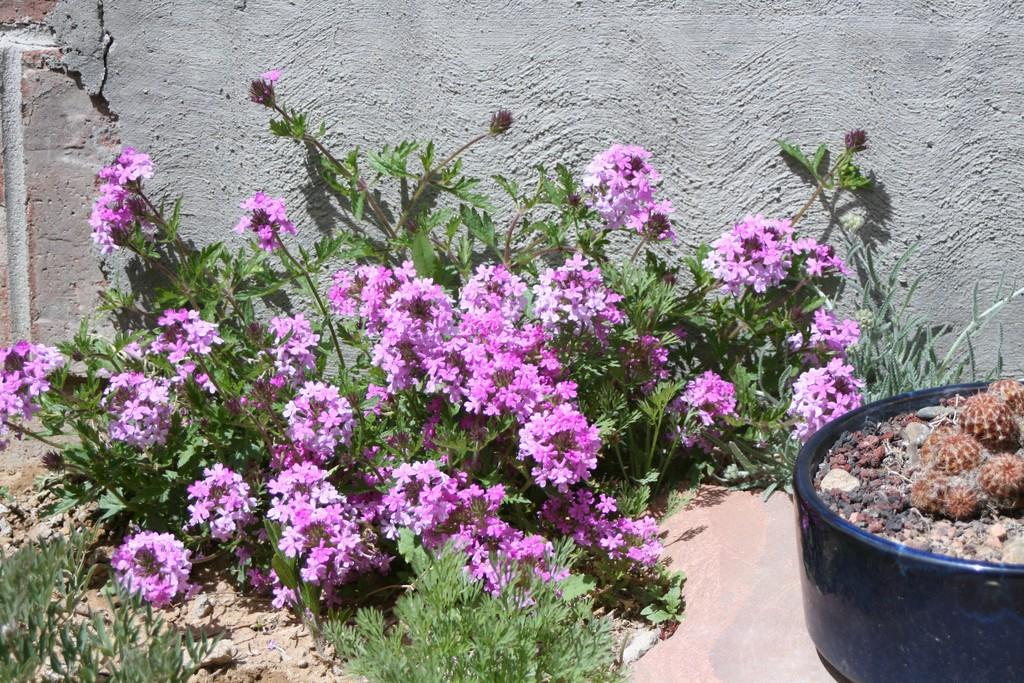What type of flowers are on the plants in the image? The plants in the image have violet flowers. What other type of plant can be seen in the image? There is a cactus plant in a flower pot in the image. What is visible in the background of the image? There is a wall visible in the image. What type of bell can be heard ringing in the image? There is no bell present in the image, and therefore no sound can be heard. 